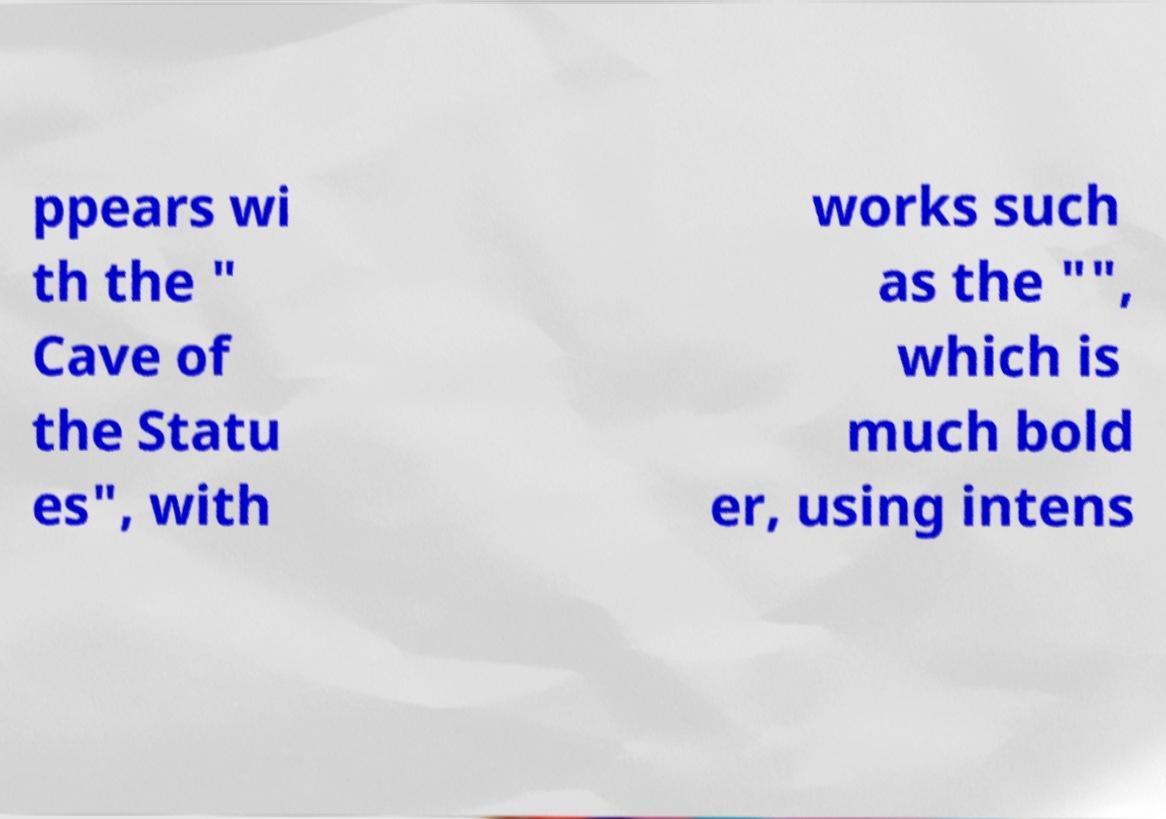Could you extract and type out the text from this image? ppears wi th the " Cave of the Statu es", with works such as the "", which is much bold er, using intens 